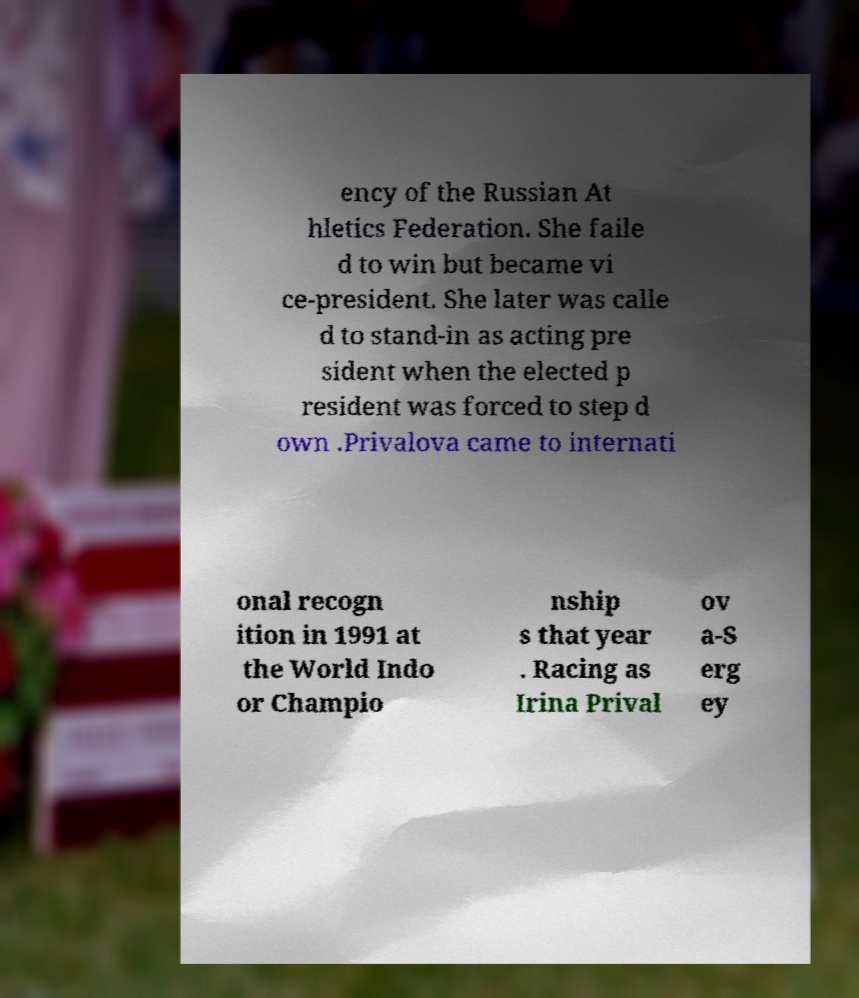I need the written content from this picture converted into text. Can you do that? ency of the Russian At hletics Federation. She faile d to win but became vi ce-president. She later was calle d to stand-in as acting pre sident when the elected p resident was forced to step d own .Privalova came to internati onal recogn ition in 1991 at the World Indo or Champio nship s that year . Racing as Irina Prival ov a-S erg ey 